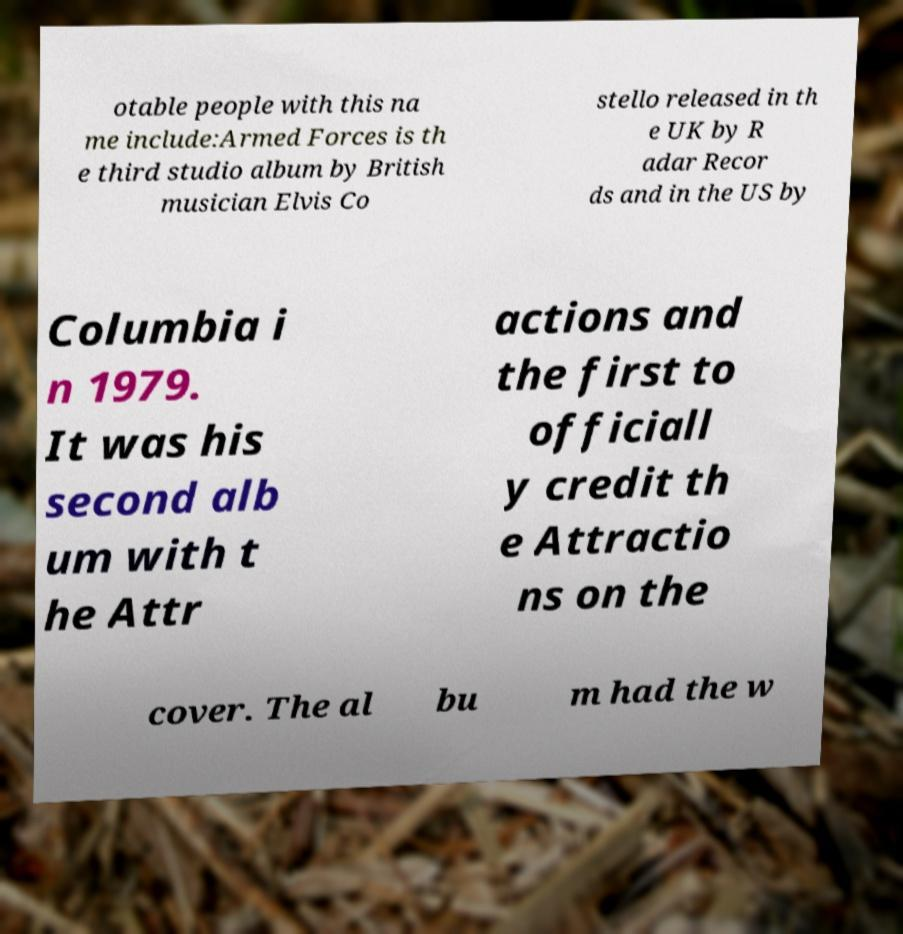What messages or text are displayed in this image? I need them in a readable, typed format. otable people with this na me include:Armed Forces is th e third studio album by British musician Elvis Co stello released in th e UK by R adar Recor ds and in the US by Columbia i n 1979. It was his second alb um with t he Attr actions and the first to officiall y credit th e Attractio ns on the cover. The al bu m had the w 